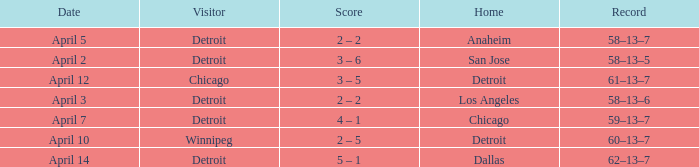Who was the home team in the game having a visitor of Chicago? Detroit. 